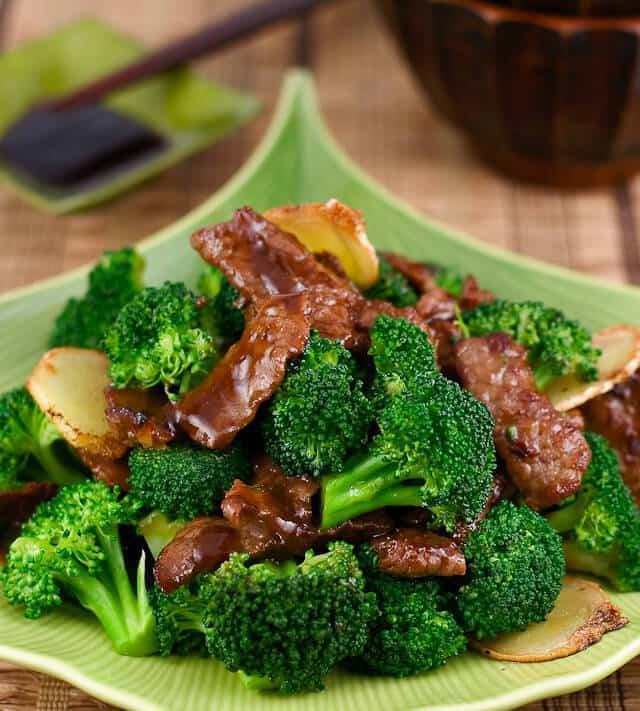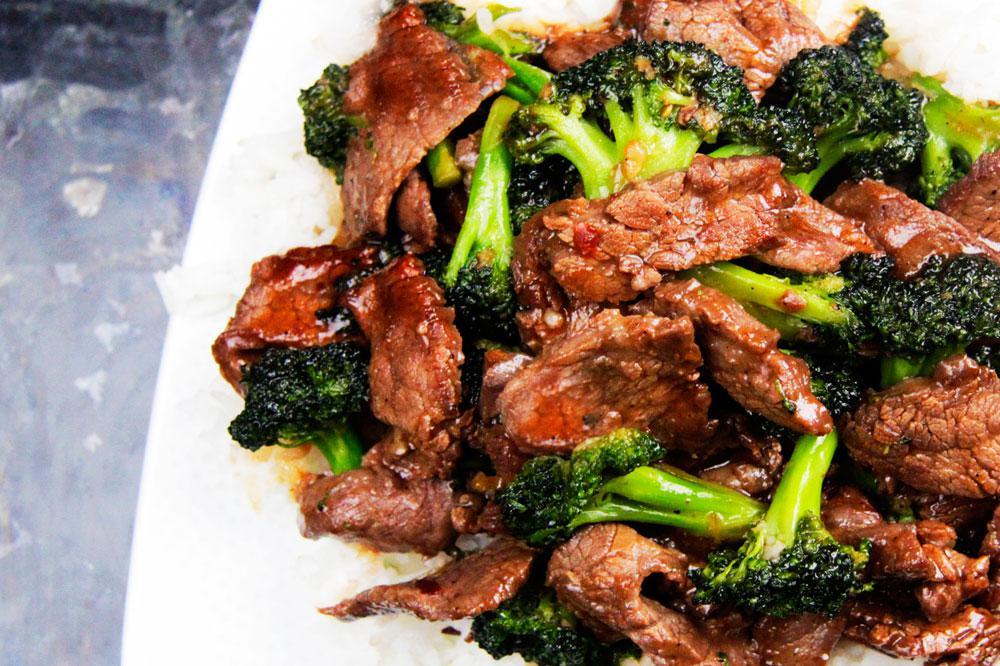The first image is the image on the left, the second image is the image on the right. Given the left and right images, does the statement "Meat and brocolli is served over rice." hold true? Answer yes or no. No. The first image is the image on the left, the second image is the image on the right. Analyze the images presented: Is the assertion "Two beef and broccoli meals are served on white plates, one with rice and one with no rice." valid? Answer yes or no. No. 